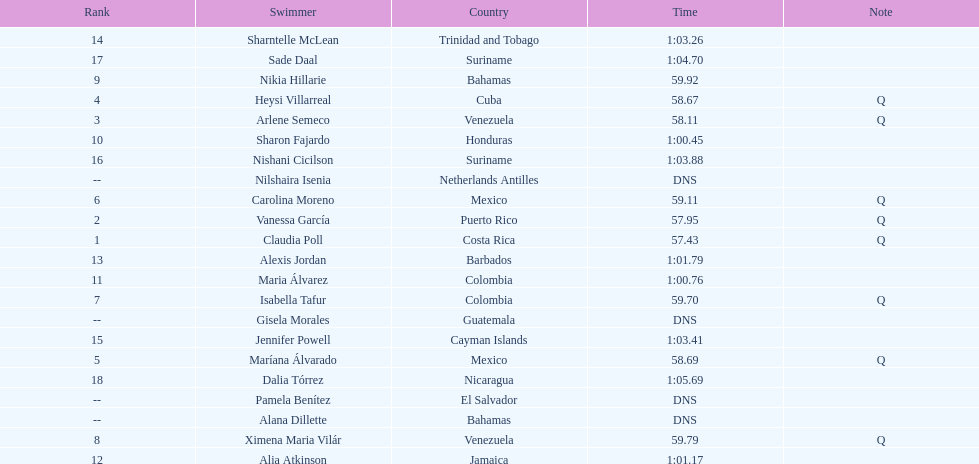Which swimmer had the longest time? Dalia Tórrez. 